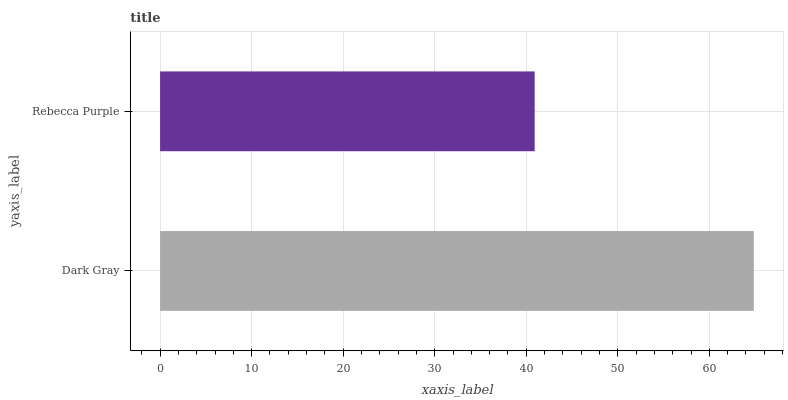Is Rebecca Purple the minimum?
Answer yes or no. Yes. Is Dark Gray the maximum?
Answer yes or no. Yes. Is Rebecca Purple the maximum?
Answer yes or no. No. Is Dark Gray greater than Rebecca Purple?
Answer yes or no. Yes. Is Rebecca Purple less than Dark Gray?
Answer yes or no. Yes. Is Rebecca Purple greater than Dark Gray?
Answer yes or no. No. Is Dark Gray less than Rebecca Purple?
Answer yes or no. No. Is Dark Gray the high median?
Answer yes or no. Yes. Is Rebecca Purple the low median?
Answer yes or no. Yes. Is Rebecca Purple the high median?
Answer yes or no. No. Is Dark Gray the low median?
Answer yes or no. No. 